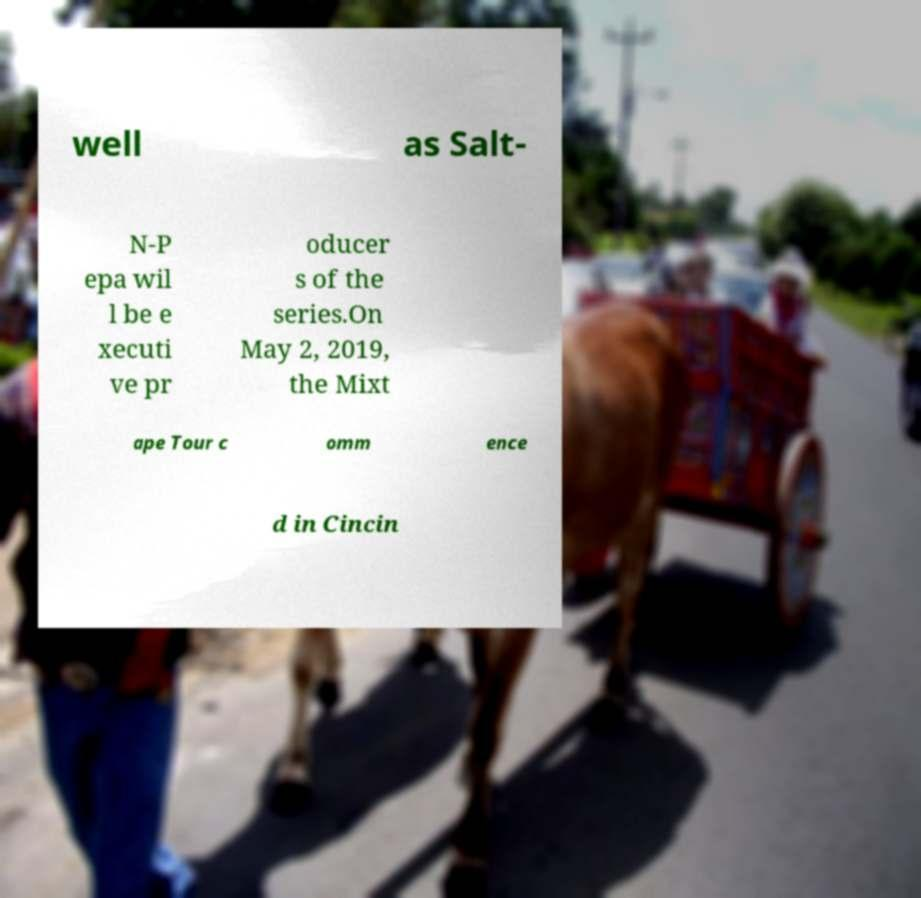Could you assist in decoding the text presented in this image and type it out clearly? well as Salt- N-P epa wil l be e xecuti ve pr oducer s of the series.On May 2, 2019, the Mixt ape Tour c omm ence d in Cincin 